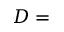<formula> <loc_0><loc_0><loc_500><loc_500>D =</formula> 